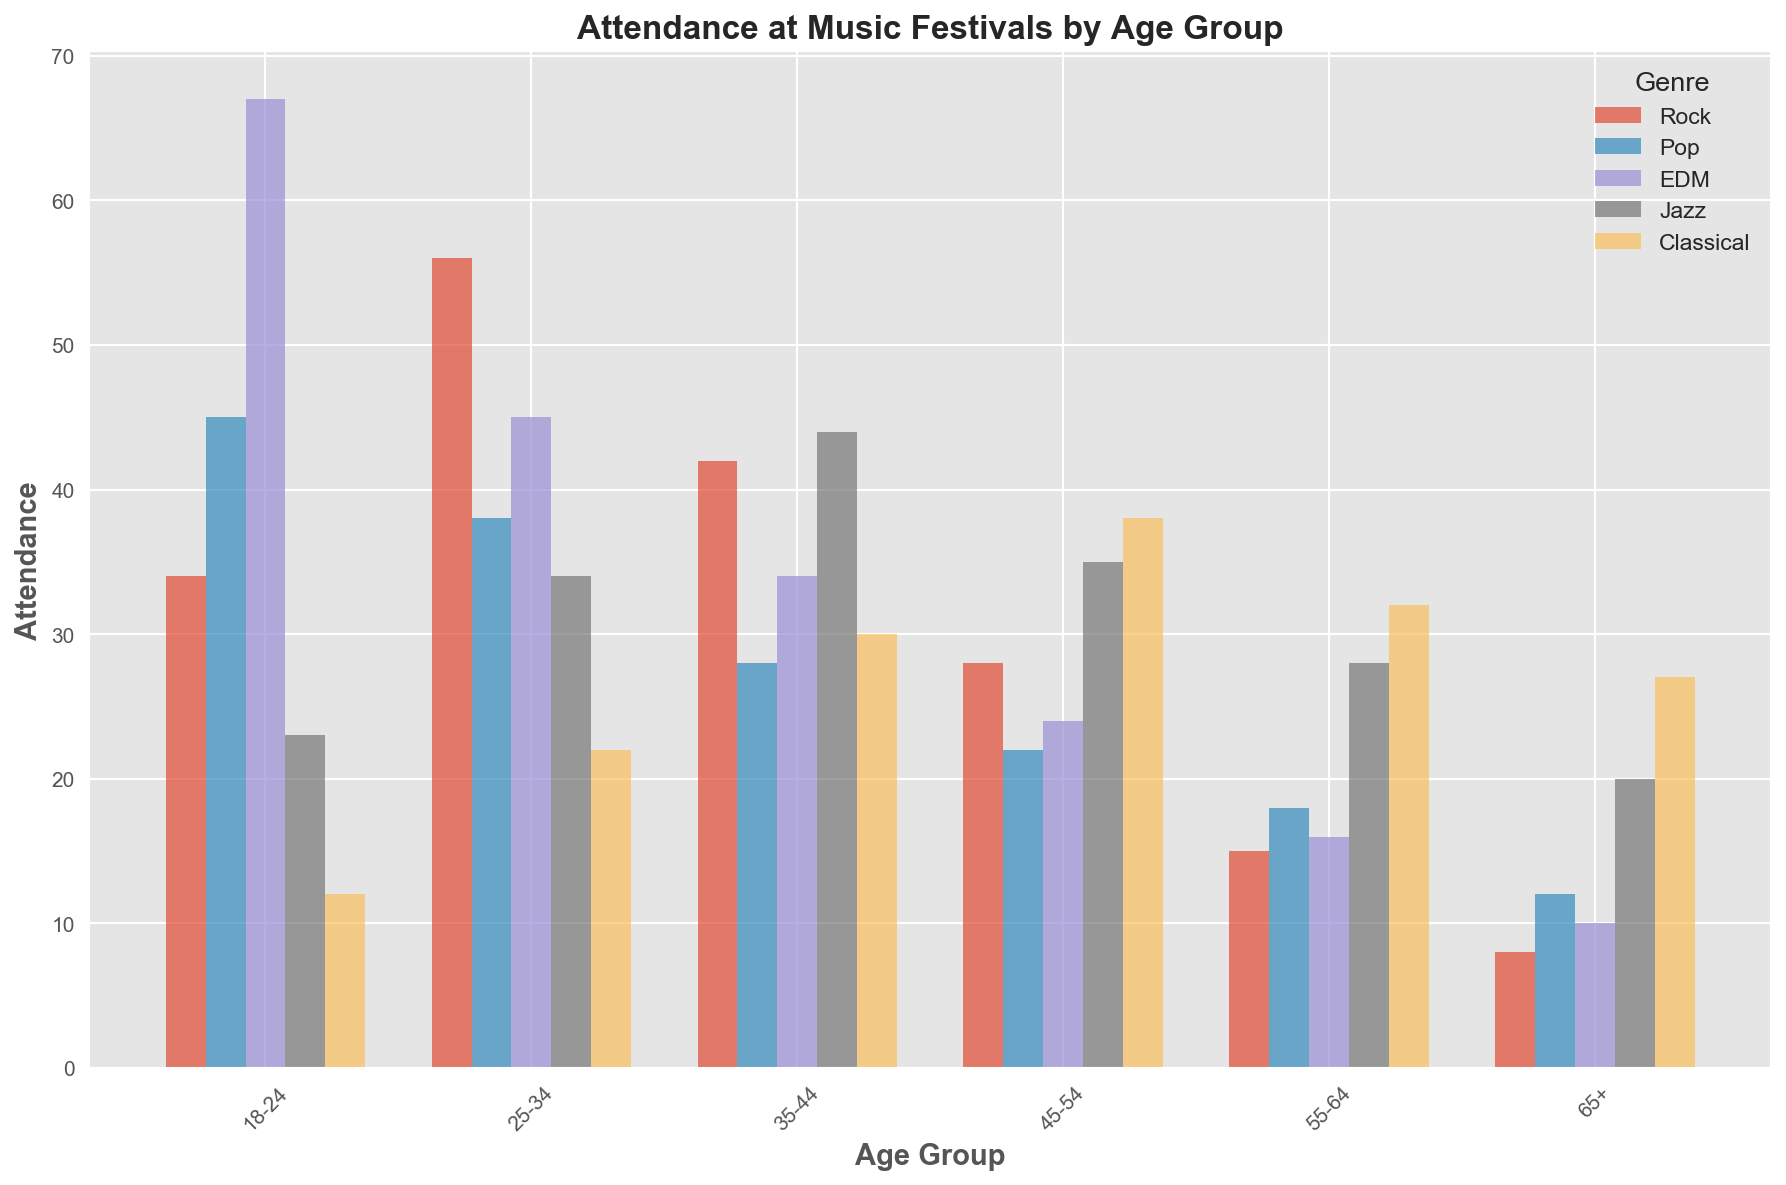What age group has the highest attendance for EDM festivals? By looking at the height of the bars for the EDM genre for each age group, the 18-24 age group has the tallest bar, indicating the highest attendance.
Answer: 18-24 Which age group attends Classical festivals the least? Comparing the heights of the bars for Classical genre across all age groups, the 18-24 age group has the shortest bar, indicating the least attendance.
Answer: 18-24 How much higher is the attendance for Rock festivals in the 25-34 age group compared to the 45-54 age group? The attendance for Rock in the 25-34 age group is 56, and in the 45-54 age group, it is 28. The difference is 56 - 28 = 28.
Answer: 28 What is the average attendance for Pop festivals across all age groups? Sum up the attendance values for Pop: 45 + 38 + 28 + 22 + 18 + 12 = 163, then divide by the number of age groups, which is 6. The average is 163 / 6 ≈ 27.17.
Answer: 27.17 Which genre has the highest overall attendance in the 55-64 age group? In the 55-64 age group, compare the heights of all genre bars: Rock (15), Pop (18), EDM (16), Jazz (28), and Classical (32). Classical has the highest bar.
Answer: Classical Is the attendance for Jazz festivals in the 35-44 age group higher than the attendance for Rock festivals in the same age group? The attendance for Jazz in the 35-44 age group is 44, and for Rock, it is 42. Since 44 is greater than 42, Jazz attendance is higher.
Answer: Yes What is the sum of attendances for Rock and Jazz festivals in the 45-54 age group? Look at the bar heights for Rock (28) and Jazz (35) in the 45-54 age group and add them. 28 + 35 = 63.
Answer: 63 Which age group has the most balanced attendance across all music genres? To find the most balanced attendance, compare the relative heights of all bars in each age group. The 35-44 age group has similar bar heights across all genres, indicating balanced attendance.
Answer: 35-44 By how much does attendance for Pop festivals in the 18-24 age group exceed the attendance for EDM festivals in the 65+ age group? Pop attendance in 18-24 is 45, and EDM attendance for 65+ is 10. The difference is 45 - 10 = 35.
Answer: 35 